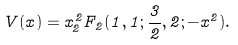Convert formula to latex. <formula><loc_0><loc_0><loc_500><loc_500>V ( x ) = x _ { 2 } ^ { 2 } F _ { 2 } ( 1 , 1 ; \frac { 3 } { 2 } , 2 ; - x ^ { 2 } ) .</formula> 